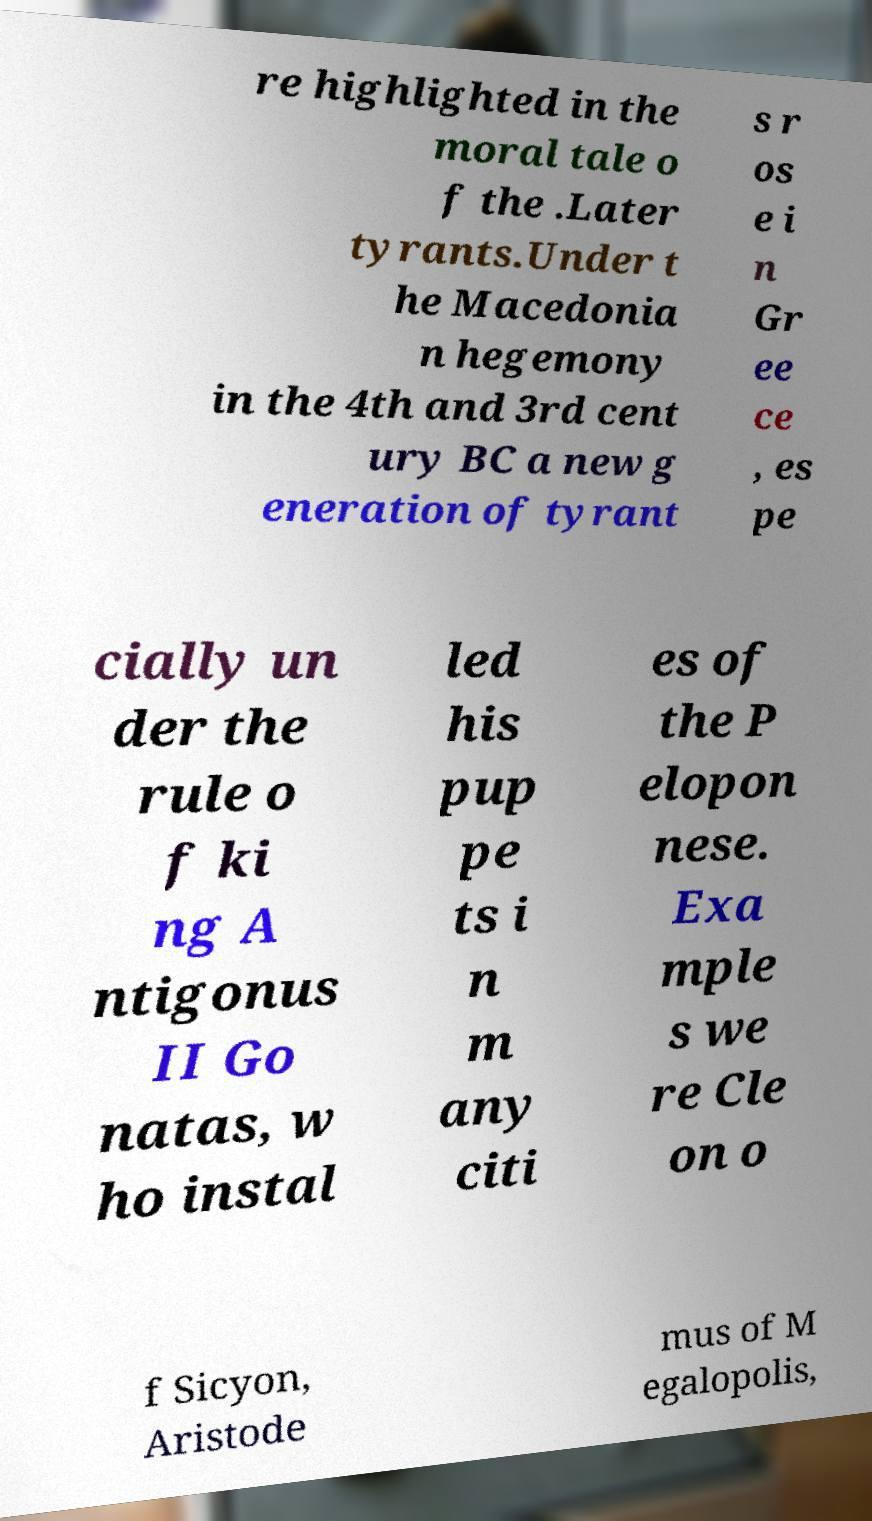Could you assist in decoding the text presented in this image and type it out clearly? re highlighted in the moral tale o f the .Later tyrants.Under t he Macedonia n hegemony in the 4th and 3rd cent ury BC a new g eneration of tyrant s r os e i n Gr ee ce , es pe cially un der the rule o f ki ng A ntigonus II Go natas, w ho instal led his pup pe ts i n m any citi es of the P elopon nese. Exa mple s we re Cle on o f Sicyon, Aristode mus of M egalopolis, 